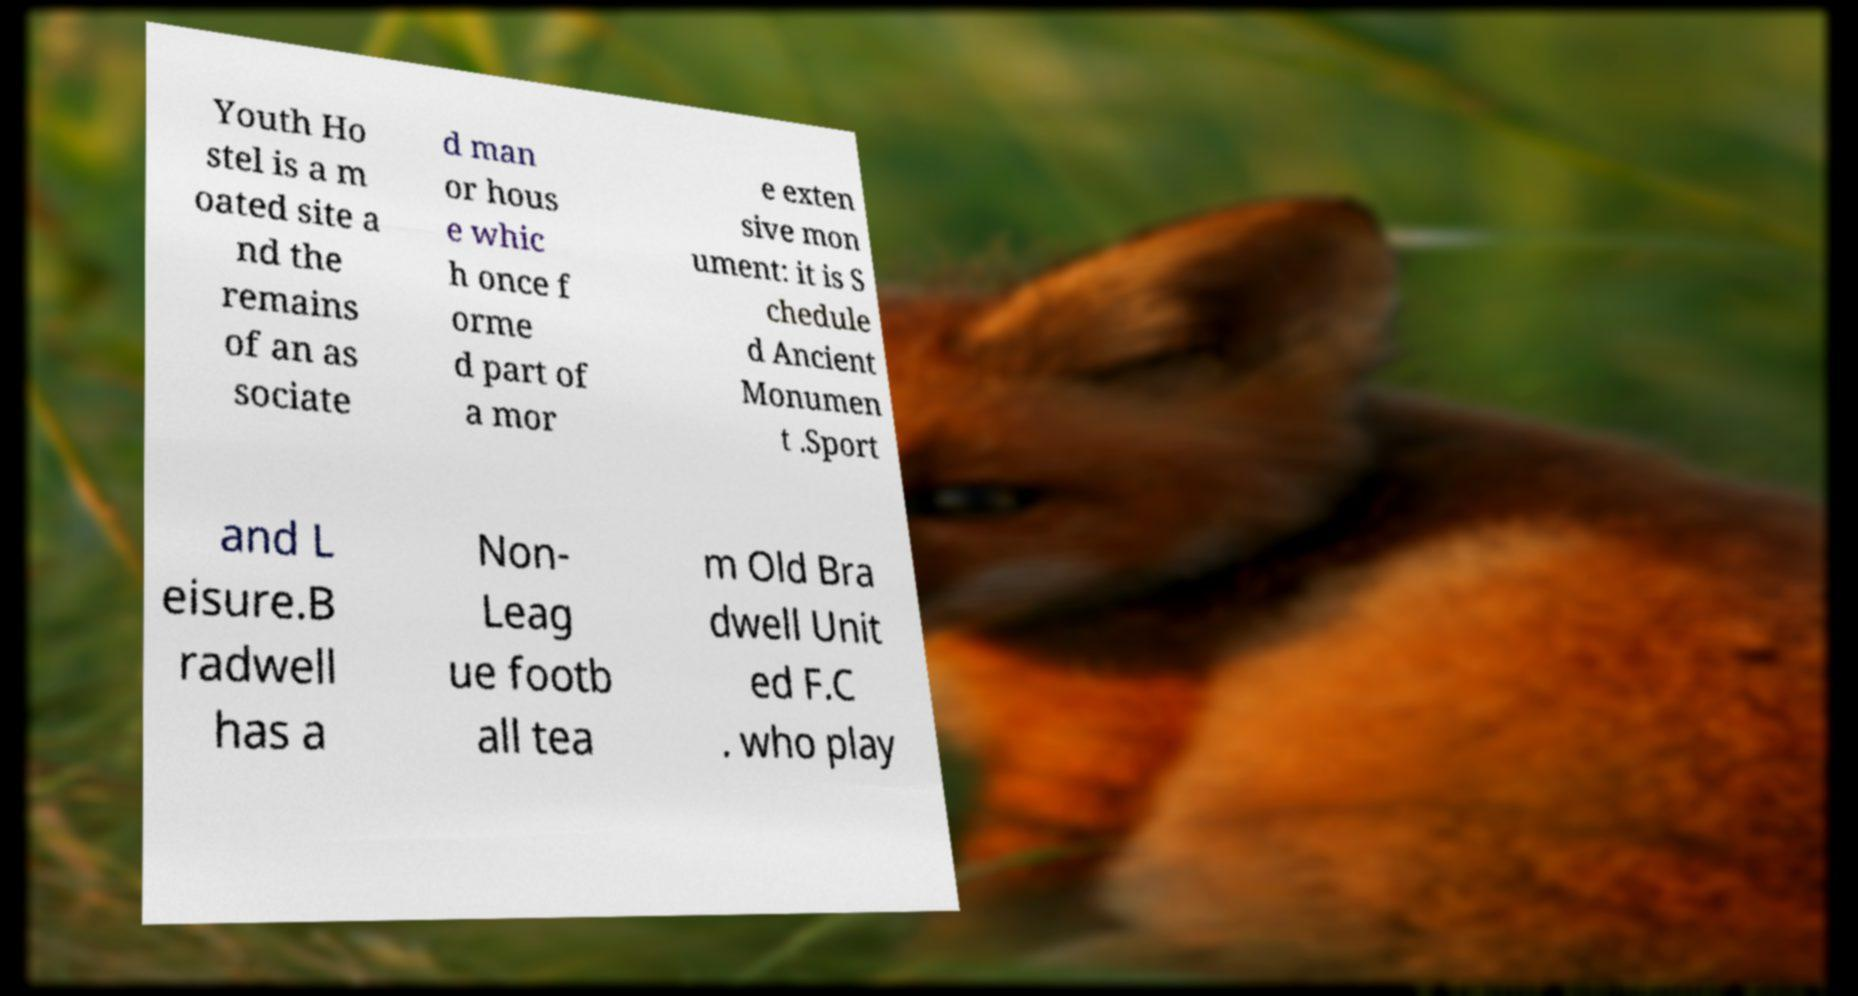For documentation purposes, I need the text within this image transcribed. Could you provide that? Youth Ho stel is a m oated site a nd the remains of an as sociate d man or hous e whic h once f orme d part of a mor e exten sive mon ument: it is S chedule d Ancient Monumen t .Sport and L eisure.B radwell has a Non- Leag ue footb all tea m Old Bra dwell Unit ed F.C . who play 